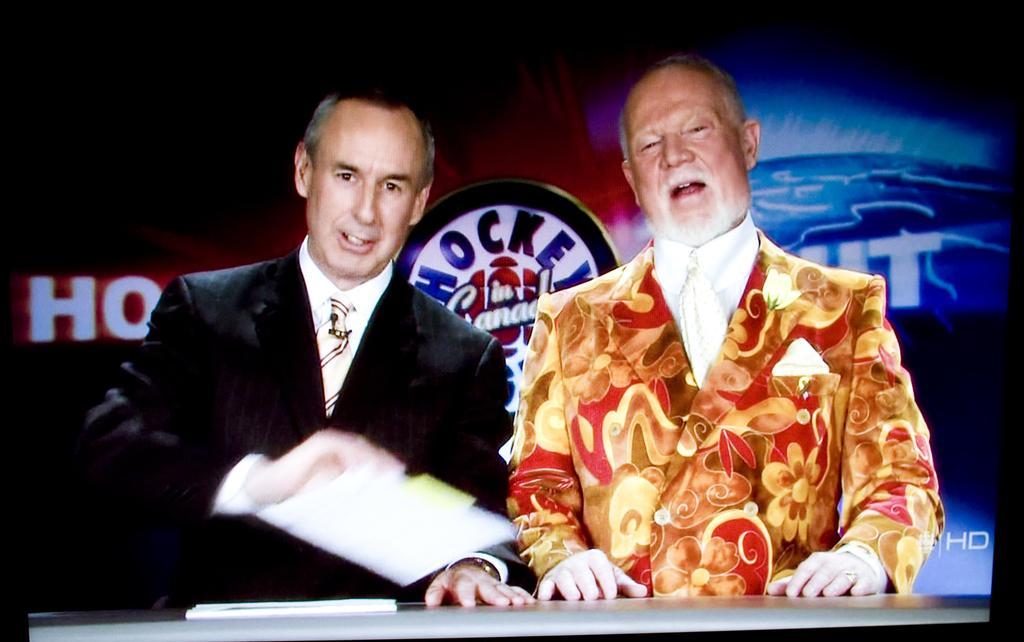Please provide a concise description of this image. In this picture we can see two men wore blazers, ties and talking and in front of them on the table we can see papers and in the background we can see a banner. 